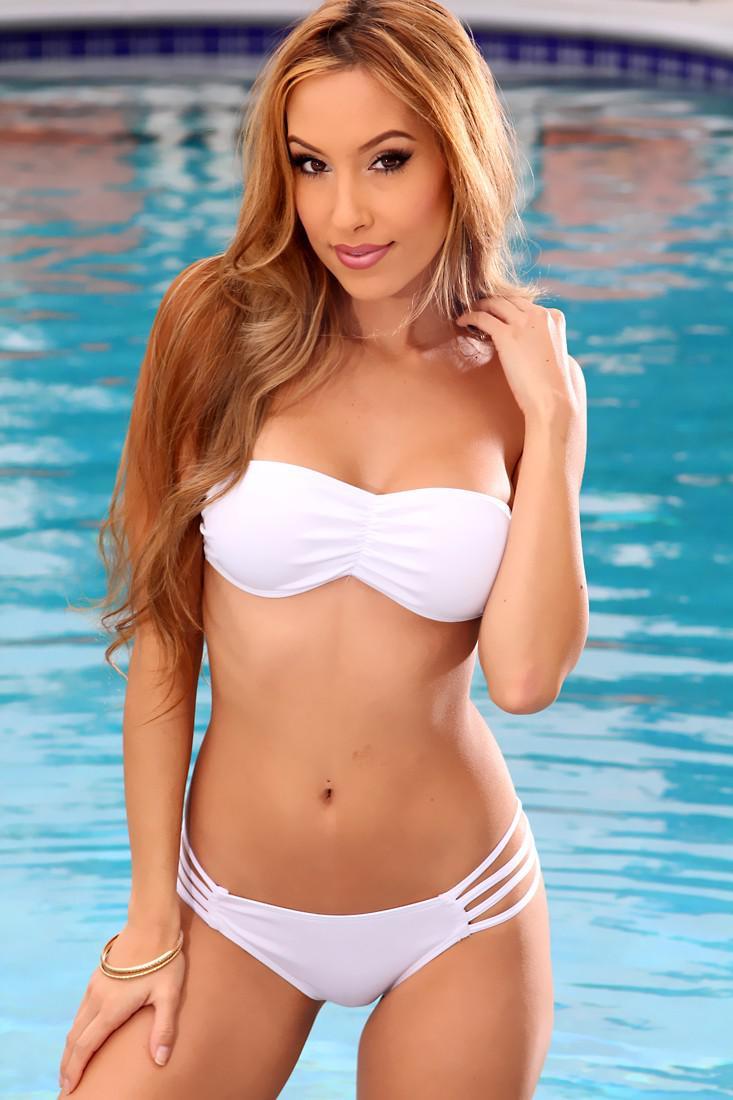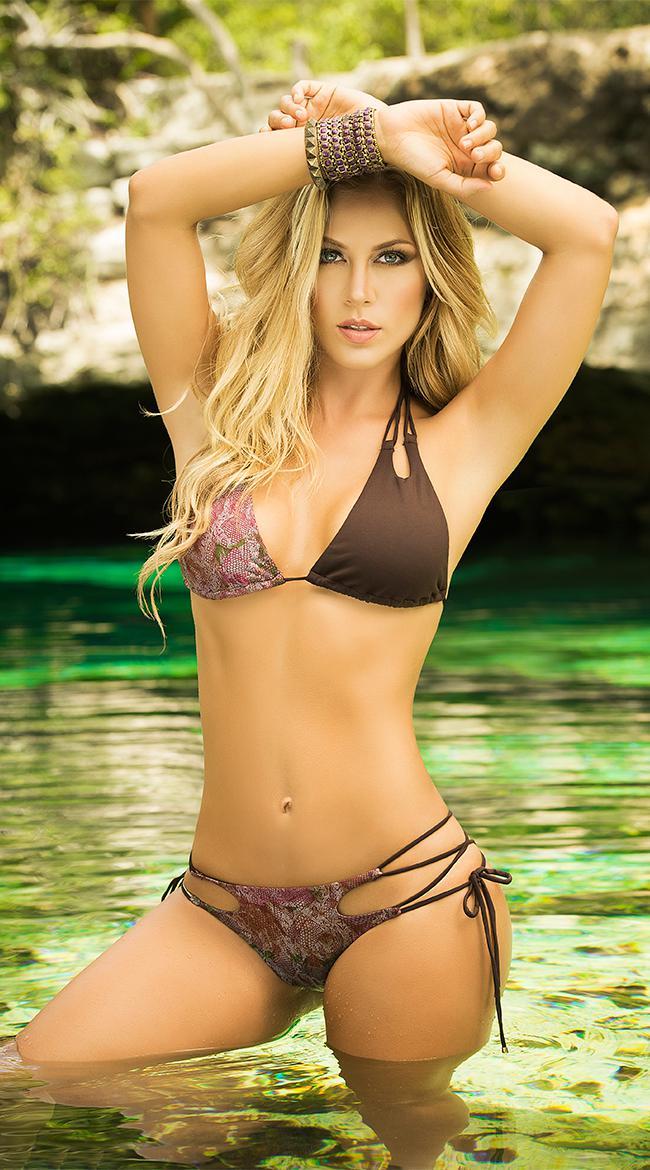The first image is the image on the left, the second image is the image on the right. For the images displayed, is the sentence "An image shows a girl in a nearly all-white bikini in front of a pool." factually correct? Answer yes or no. Yes. The first image is the image on the left, the second image is the image on the right. For the images shown, is this caption "In 1 of the images, 1 girl is holding her hands above her head." true? Answer yes or no. Yes. 